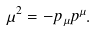<formula> <loc_0><loc_0><loc_500><loc_500>\mu ^ { 2 } = - p _ { \mu } p ^ { \mu } .</formula> 